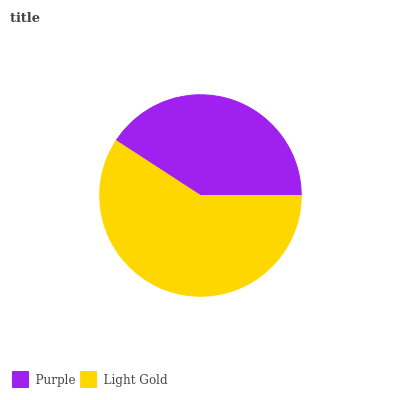Is Purple the minimum?
Answer yes or no. Yes. Is Light Gold the maximum?
Answer yes or no. Yes. Is Light Gold the minimum?
Answer yes or no. No. Is Light Gold greater than Purple?
Answer yes or no. Yes. Is Purple less than Light Gold?
Answer yes or no. Yes. Is Purple greater than Light Gold?
Answer yes or no. No. Is Light Gold less than Purple?
Answer yes or no. No. Is Light Gold the high median?
Answer yes or no. Yes. Is Purple the low median?
Answer yes or no. Yes. Is Purple the high median?
Answer yes or no. No. Is Light Gold the low median?
Answer yes or no. No. 